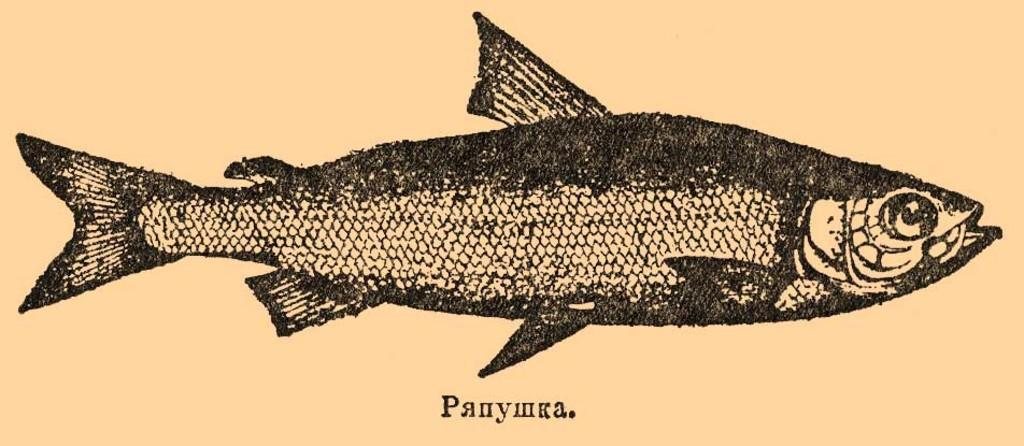What is the main subject of the image? The main subject of the image is a print of a fish. Is there any text present in the image? Yes, there is text on the bottom of the image. How many thumbs can be seen holding the plate in the image? There are no thumbs or plates present in the image; it only features a print of a fish and text. 